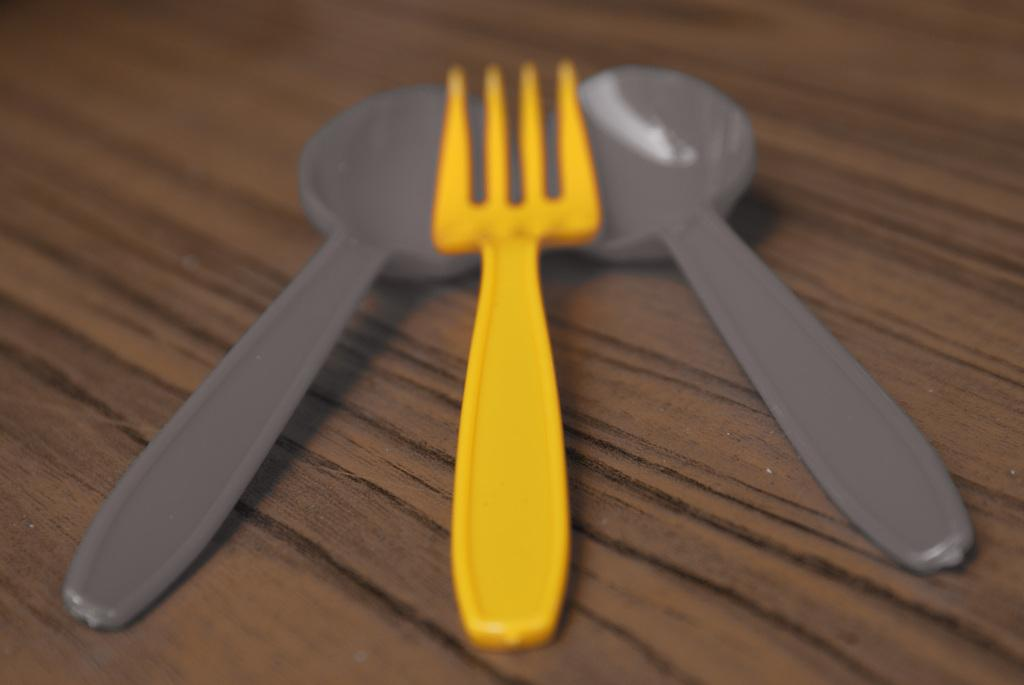What is the main object in the center of the image? There is a table in the center of the image. What utensils can be seen on the table? There are two spoons and one fork on the table. What type of ship is sailing in the background of the image? There is no ship visible in the image; it only features a table with utensils. 